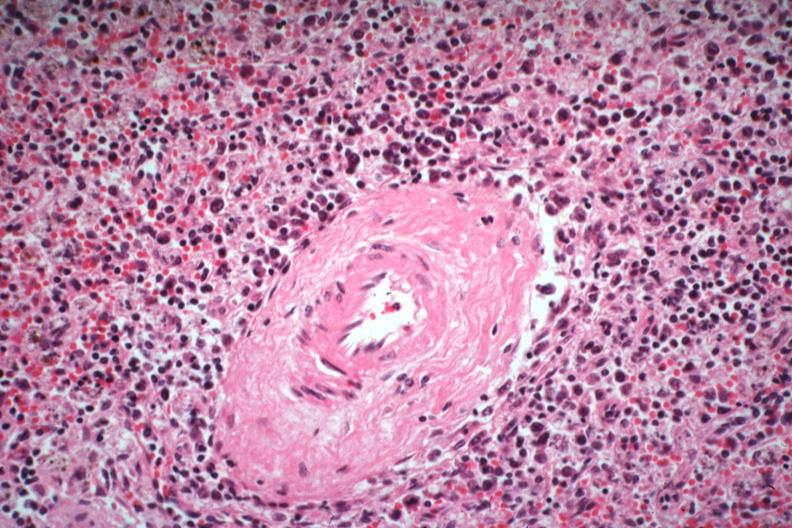what is present?
Answer the question using a single word or phrase. Hematologic 